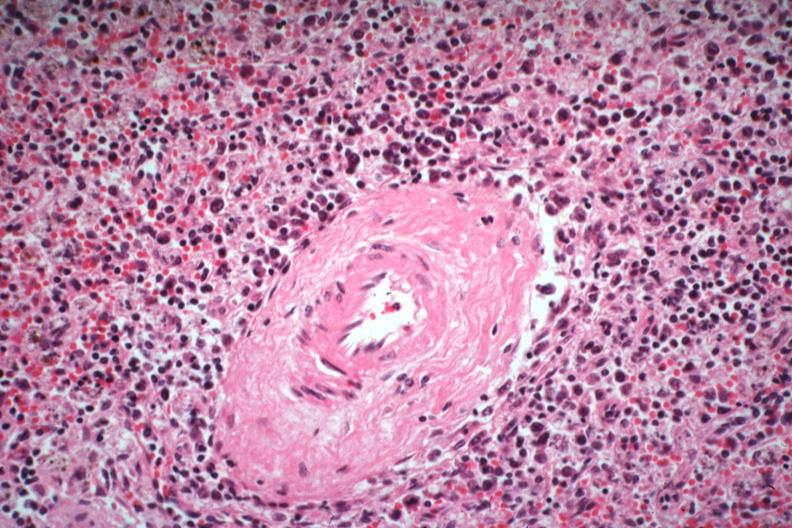what is present?
Answer the question using a single word or phrase. Hematologic 